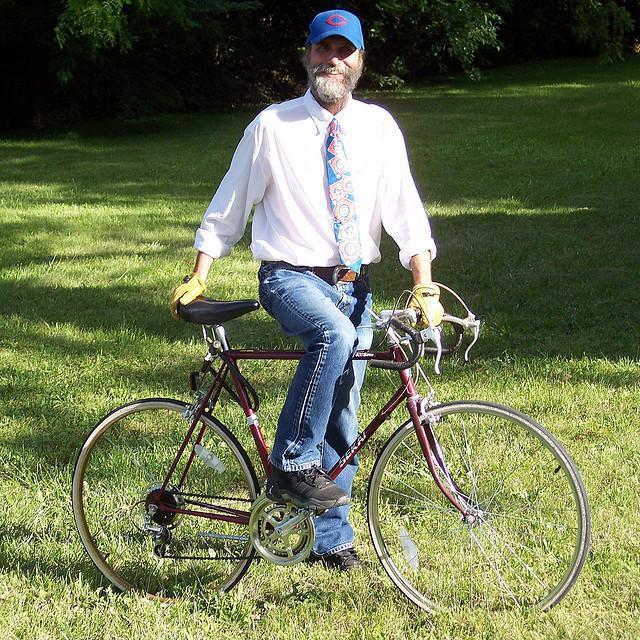How many bikes are shown?
Give a very brief answer. 1. 